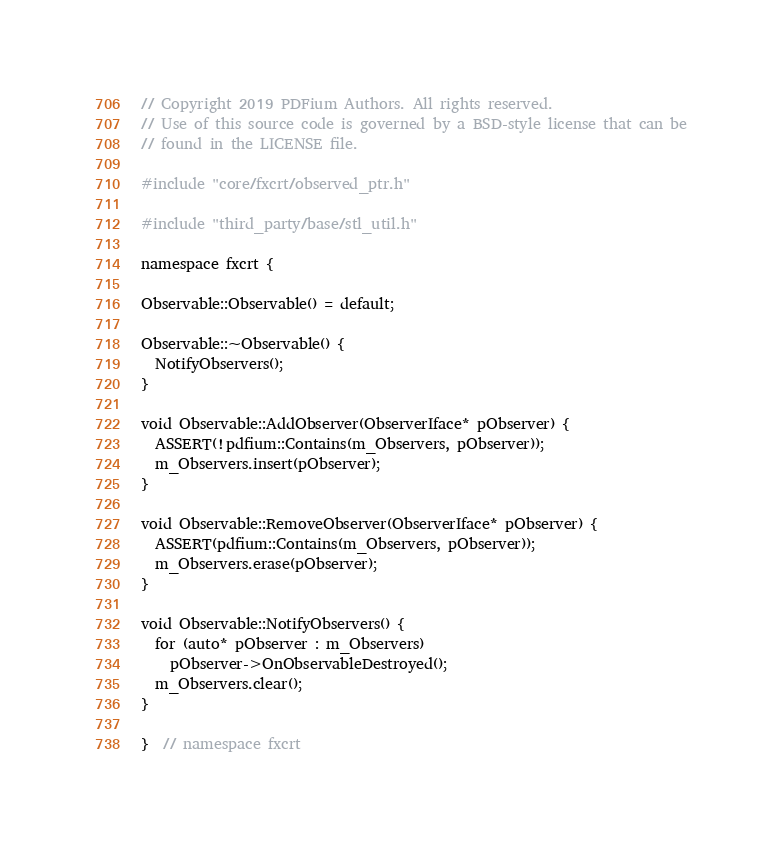Convert code to text. <code><loc_0><loc_0><loc_500><loc_500><_C++_>// Copyright 2019 PDFium Authors. All rights reserved.
// Use of this source code is governed by a BSD-style license that can be
// found in the LICENSE file.

#include "core/fxcrt/observed_ptr.h"

#include "third_party/base/stl_util.h"

namespace fxcrt {

Observable::Observable() = default;

Observable::~Observable() {
  NotifyObservers();
}

void Observable::AddObserver(ObserverIface* pObserver) {
  ASSERT(!pdfium::Contains(m_Observers, pObserver));
  m_Observers.insert(pObserver);
}

void Observable::RemoveObserver(ObserverIface* pObserver) {
  ASSERT(pdfium::Contains(m_Observers, pObserver));
  m_Observers.erase(pObserver);
}

void Observable::NotifyObservers() {
  for (auto* pObserver : m_Observers)
    pObserver->OnObservableDestroyed();
  m_Observers.clear();
}

}  // namespace fxcrt
</code> 